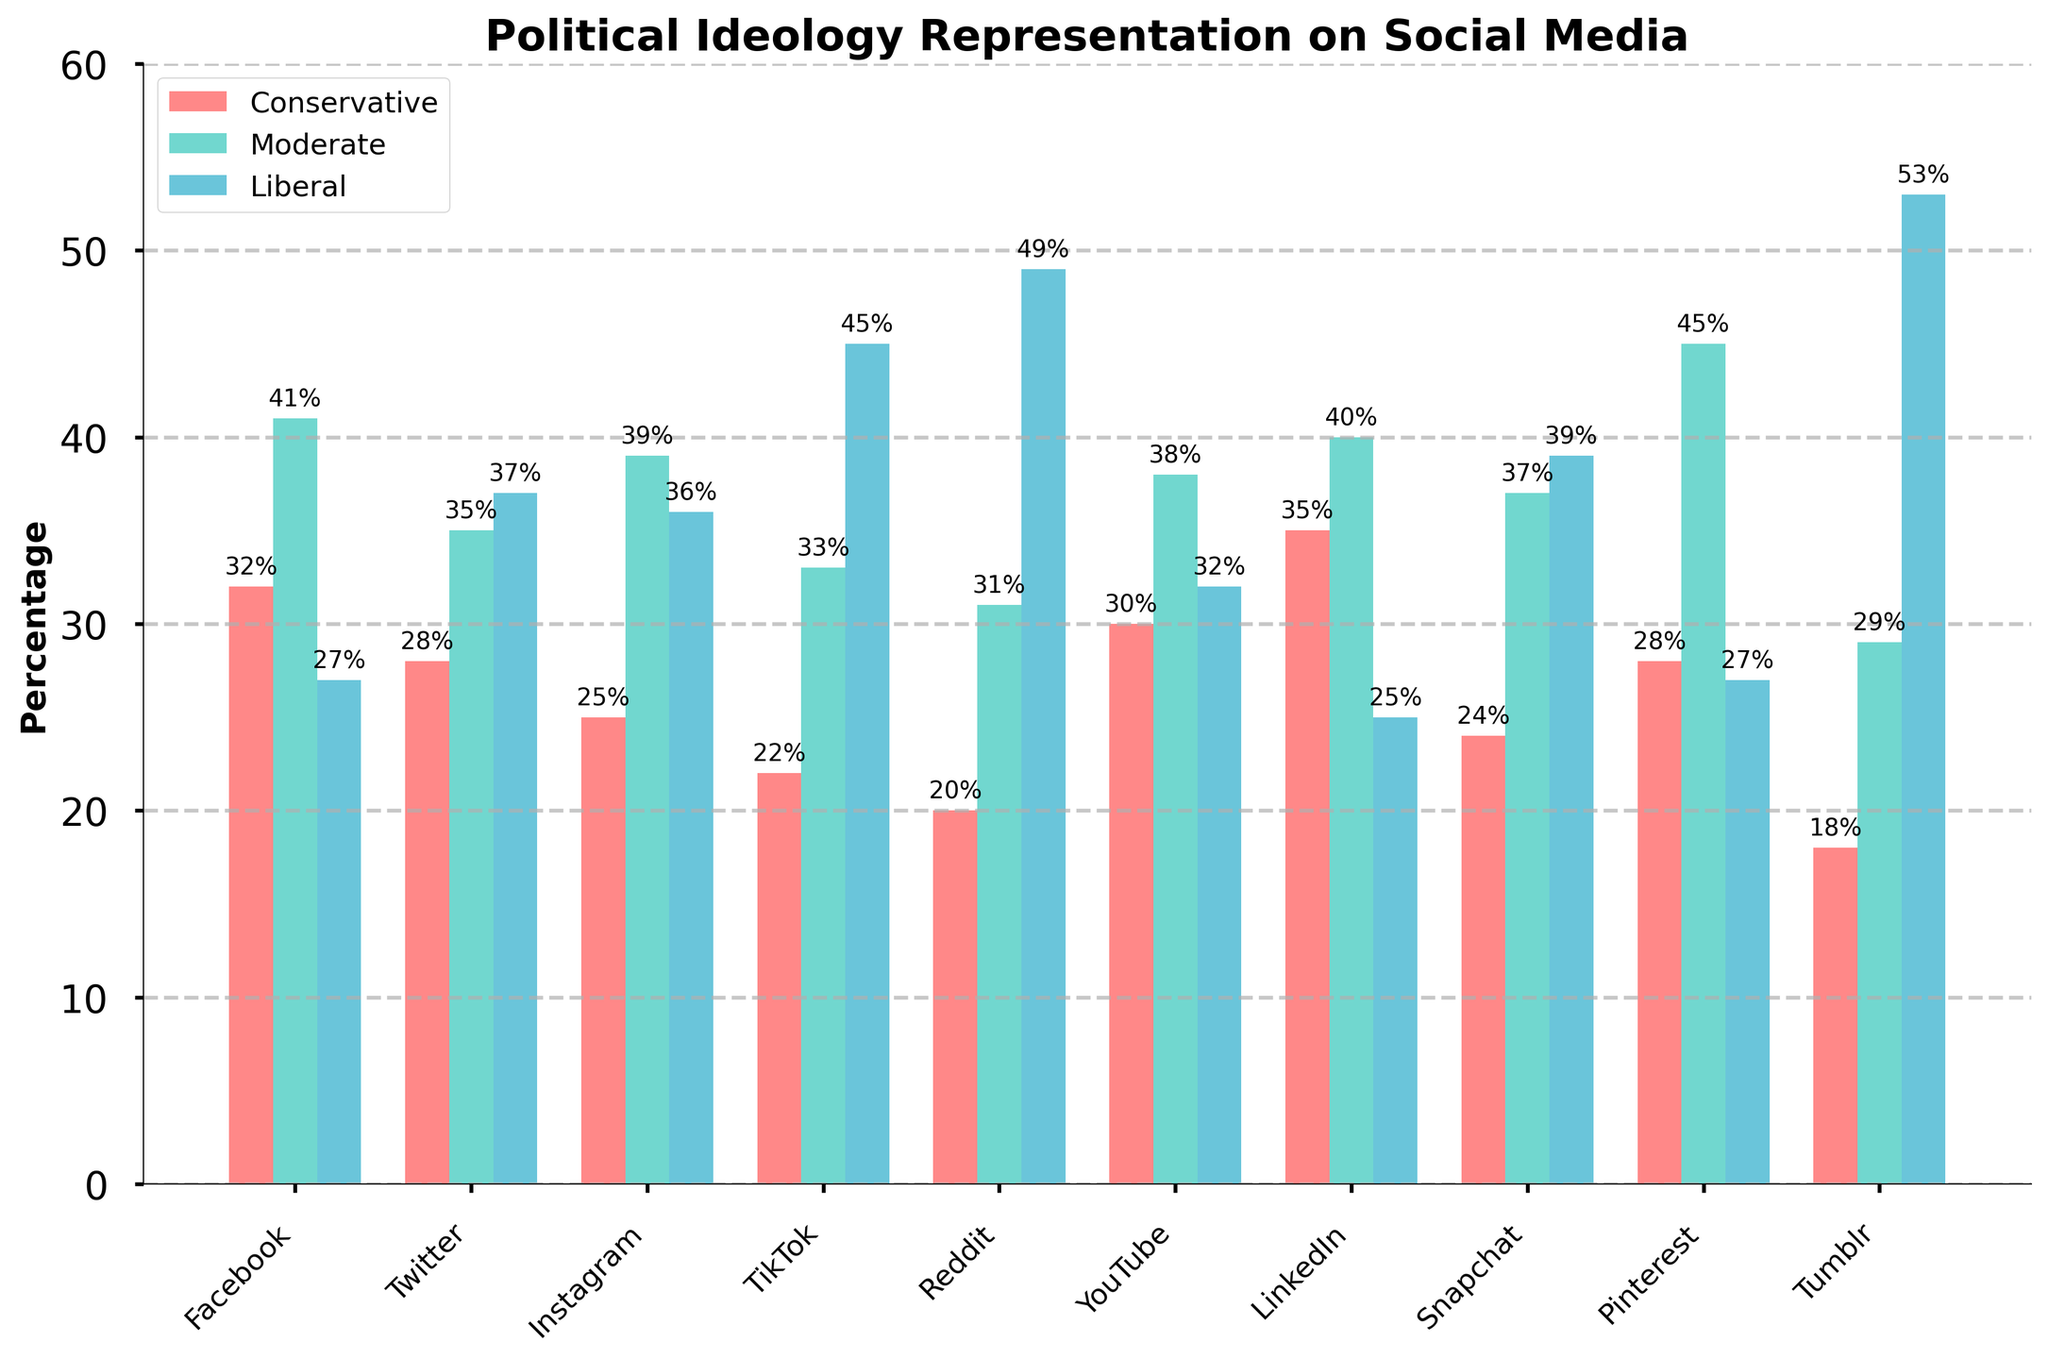What social media platform has the highest percentage of liberals? By looking at the heights of the blue bars, you can see that Tumblr has the highest percentage of liberals with the bar reaching 53%.
Answer: Tumblr Which platform has the least representation of conservatives? By examining the heights of the red bars, you can see that Tumblr has the lowest percentage of conservatives with the bar at 18%.
Answer: Tumblr What is the difference in moderate representation between Pinterest and LinkedIn? The height of the green bar for Pinterest is 45%, and for LinkedIn, it is 40%. Subtracting these, 45% - 40% = 5%.
Answer: 5% Which social media platform has the largest percentage gap between conservative and liberal representation? To find this, you need to check the difference between the red and blue bars for each platform. For Tumblr, the difference is 53% - 18% = 35%, which is the largest gap.
Answer: Tumblr What is the average percentage of liberal representation across all platforms? Add up the percentages of liberal representation for all platforms and divide by the number of platforms: (27 + 37 + 36 + 45 + 49 + 32 + 25 + 39 + 27 + 53) / 10 = 37%.
Answer: 37% Which platform has the closest percentage representation among all three ideologies? Compare the red, green, and blue bars for each platform. Facebook has the closest percentages: Conservative 32%, Moderate 41%, Liberal 27%, with the differences being 9% and 14%.
Answer: Facebook Are there any platforms where conservatives are represented more than liberals? You can visually inspect the red and blue bars and see that Facebook, LinkedIn, and YouTube have higher red bars than blue bars, meaning conservatives are more represented than liberals on these platforms.
Answer: Facebook, LinkedIn, YouTube Which platform has the highest representation of moderate ideology? By looking at the heights of the green bars, you can see that Pinterest has the highest percentage of moderates with the bar reaching 45%.
Answer: Pinterest What is the sum of conservative and liberal representation on YouTube? The heights of the red and blue bars for YouTube are 30% and 32%, respectively. Adding these gives 30% + 32% = 62%.
Answer: 62% Is there any platform where conservative representation is equal to the moderate representation of another platform? Examine the heights of the red bars and compare them to the green bars of other platforms. The conservative representation of LinkedIn (35%) is equal to the moderate representation of Facebook (41%).
Answer: Yes, LinkedIn and Facebook 